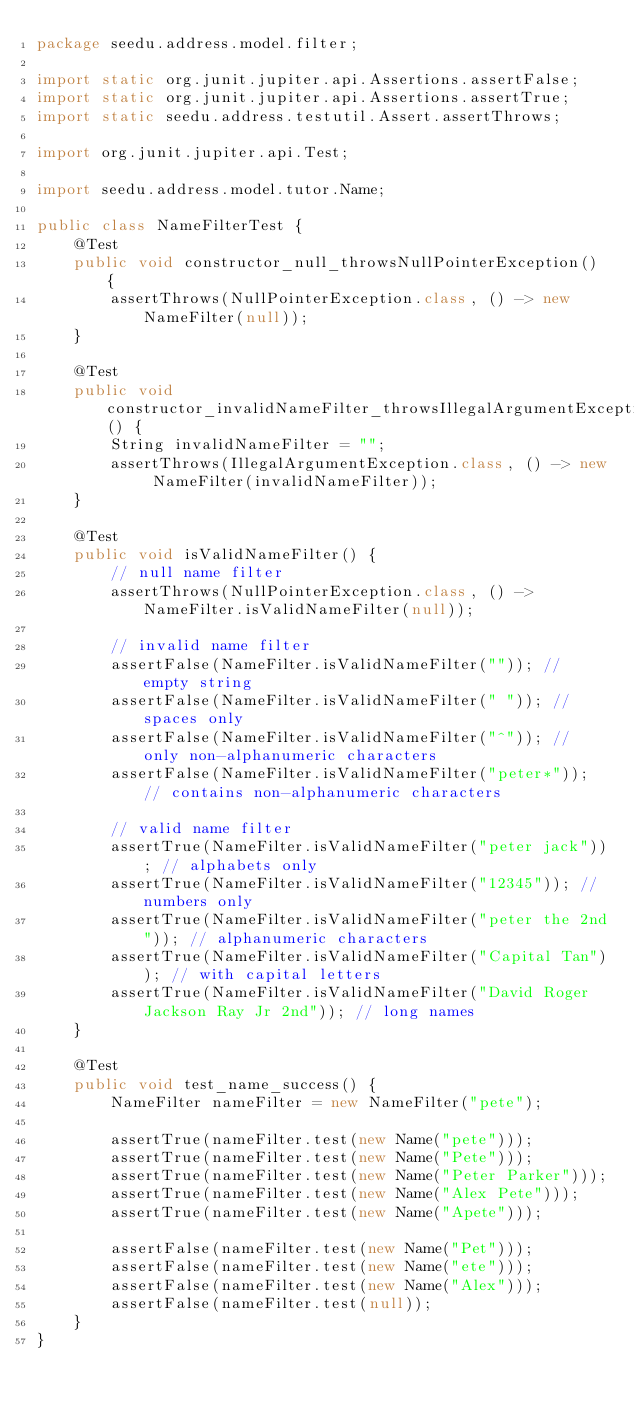<code> <loc_0><loc_0><loc_500><loc_500><_Java_>package seedu.address.model.filter;

import static org.junit.jupiter.api.Assertions.assertFalse;
import static org.junit.jupiter.api.Assertions.assertTrue;
import static seedu.address.testutil.Assert.assertThrows;

import org.junit.jupiter.api.Test;

import seedu.address.model.tutor.Name;

public class NameFilterTest {
    @Test
    public void constructor_null_throwsNullPointerException() {
        assertThrows(NullPointerException.class, () -> new NameFilter(null));
    }

    @Test
    public void constructor_invalidNameFilter_throwsIllegalArgumentException() {
        String invalidNameFilter = "";
        assertThrows(IllegalArgumentException.class, () -> new NameFilter(invalidNameFilter));
    }

    @Test
    public void isValidNameFilter() {
        // null name filter
        assertThrows(NullPointerException.class, () -> NameFilter.isValidNameFilter(null));

        // invalid name filter
        assertFalse(NameFilter.isValidNameFilter("")); // empty string
        assertFalse(NameFilter.isValidNameFilter(" ")); // spaces only
        assertFalse(NameFilter.isValidNameFilter("^")); // only non-alphanumeric characters
        assertFalse(NameFilter.isValidNameFilter("peter*")); // contains non-alphanumeric characters

        // valid name filter
        assertTrue(NameFilter.isValidNameFilter("peter jack")); // alphabets only
        assertTrue(NameFilter.isValidNameFilter("12345")); // numbers only
        assertTrue(NameFilter.isValidNameFilter("peter the 2nd")); // alphanumeric characters
        assertTrue(NameFilter.isValidNameFilter("Capital Tan")); // with capital letters
        assertTrue(NameFilter.isValidNameFilter("David Roger Jackson Ray Jr 2nd")); // long names
    }

    @Test
    public void test_name_success() {
        NameFilter nameFilter = new NameFilter("pete");

        assertTrue(nameFilter.test(new Name("pete")));
        assertTrue(nameFilter.test(new Name("Pete")));
        assertTrue(nameFilter.test(new Name("Peter Parker")));
        assertTrue(nameFilter.test(new Name("Alex Pete")));
        assertTrue(nameFilter.test(new Name("Apete")));

        assertFalse(nameFilter.test(new Name("Pet")));
        assertFalse(nameFilter.test(new Name("ete")));
        assertFalse(nameFilter.test(new Name("Alex")));
        assertFalse(nameFilter.test(null));
    }
}
</code> 